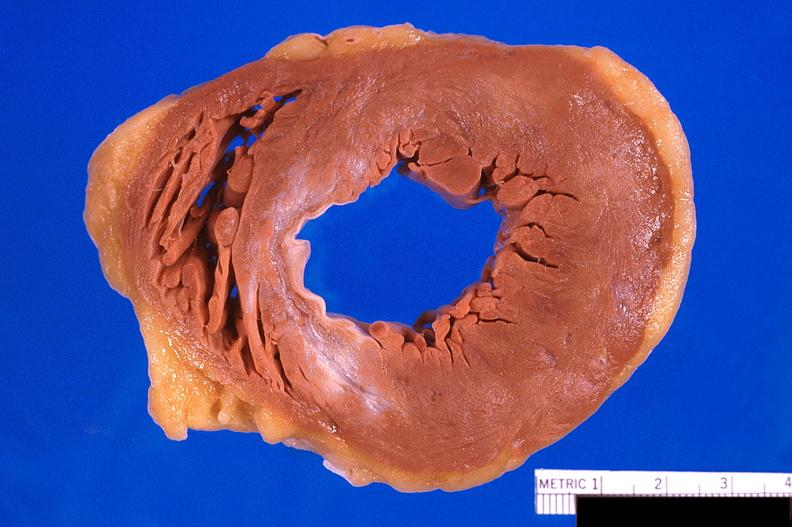where is this?
Answer the question using a single word or phrase. Heart 